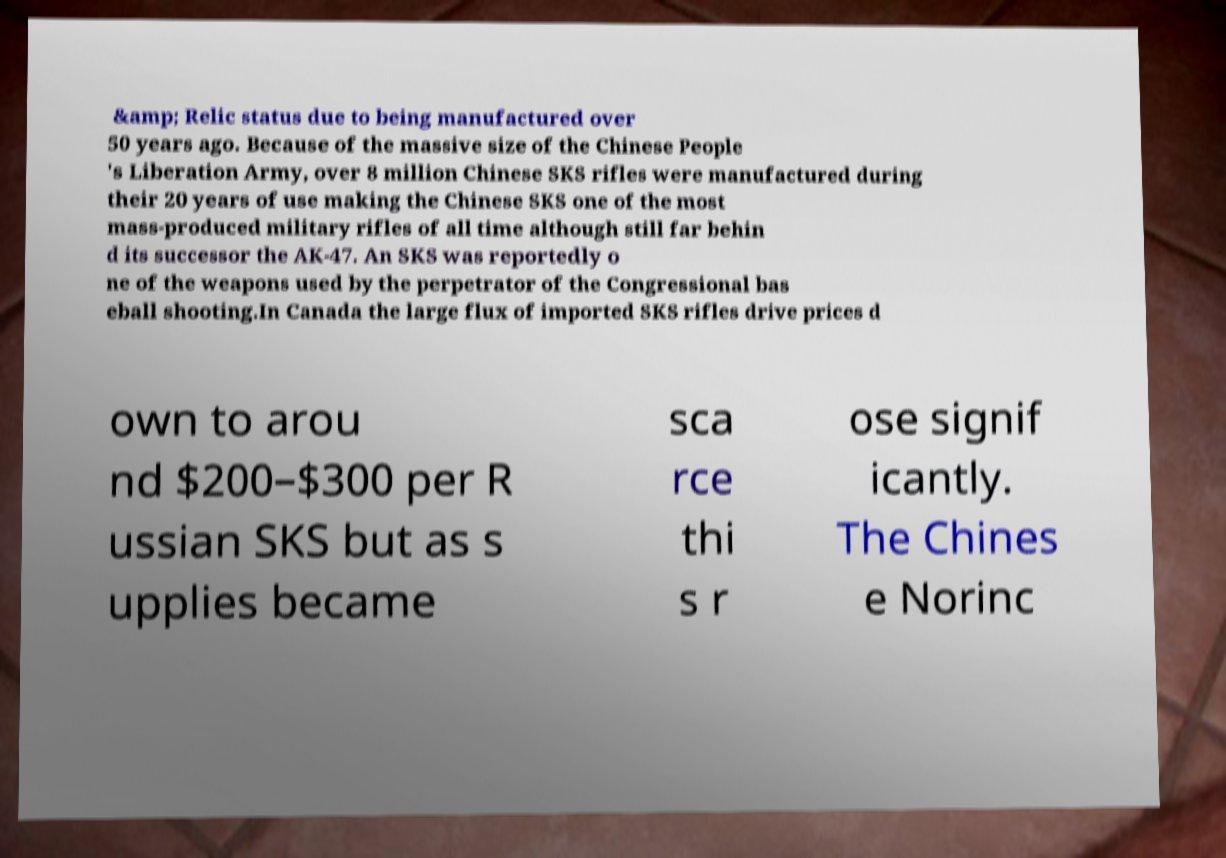Please read and relay the text visible in this image. What does it say? &amp; Relic status due to being manufactured over 50 years ago. Because of the massive size of the Chinese People 's Liberation Army, over 8 million Chinese SKS rifles were manufactured during their 20 years of use making the Chinese SKS one of the most mass-produced military rifles of all time although still far behin d its successor the AK-47. An SKS was reportedly o ne of the weapons used by the perpetrator of the Congressional bas eball shooting.In Canada the large flux of imported SKS rifles drive prices d own to arou nd $200–$300 per R ussian SKS but as s upplies became sca rce thi s r ose signif icantly. The Chines e Norinc 